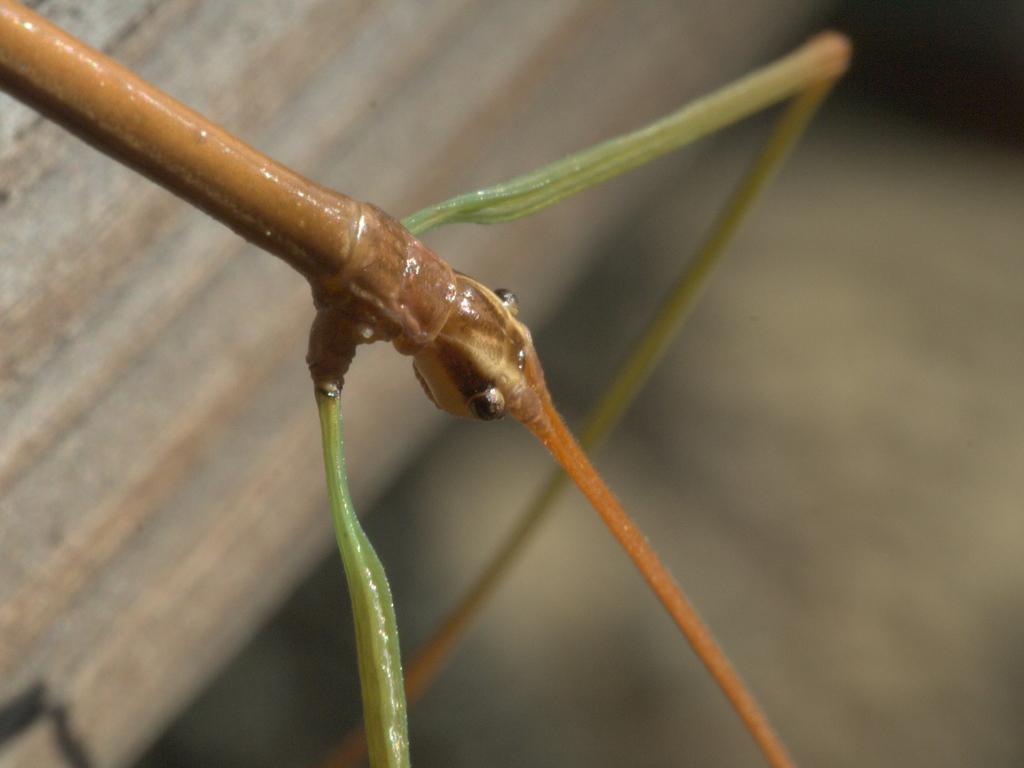Could you give a brief overview of what you see in this image? In this image we can see an insect. In the background of the image there is a blur background. 